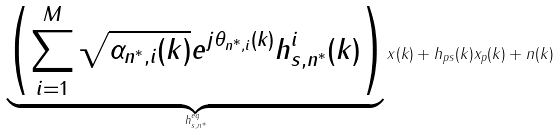Convert formula to latex. <formula><loc_0><loc_0><loc_500><loc_500>\underbrace { \left ( \sum _ { i = 1 } ^ { M } \sqrt { \alpha _ { n ^ { * } , i } ( k ) } e ^ { j \theta _ { n ^ { * } , i } ( k ) } h ^ { i } _ { s , n ^ { * } } ( k ) \right ) } _ { h ^ { e q } _ { s , n ^ { * } } } x ( k ) + h _ { p s } ( k ) x _ { p } ( k ) + n ( k )</formula> 